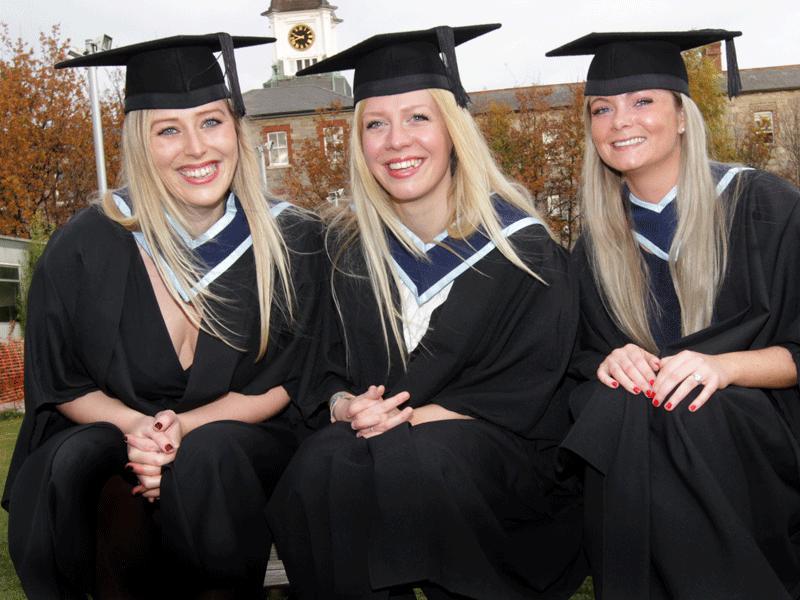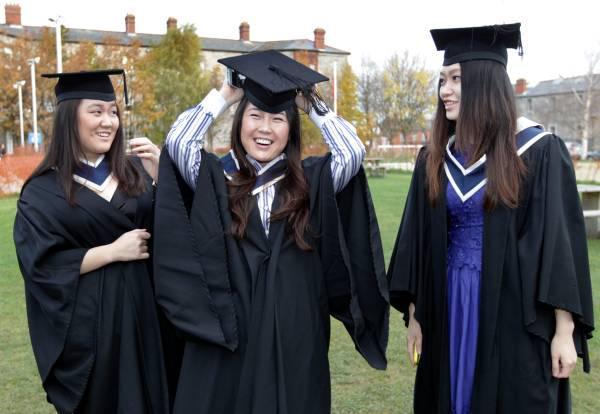The first image is the image on the left, the second image is the image on the right. Evaluate the accuracy of this statement regarding the images: "An image includes three blond girls in graduation garb, posed side-by-side in a straight row.". Is it true? Answer yes or no. Yes. The first image is the image on the left, the second image is the image on the right. Examine the images to the left and right. Is the description "There are only women in the left image, but both men and women on the right." accurate? Answer yes or no. No. 